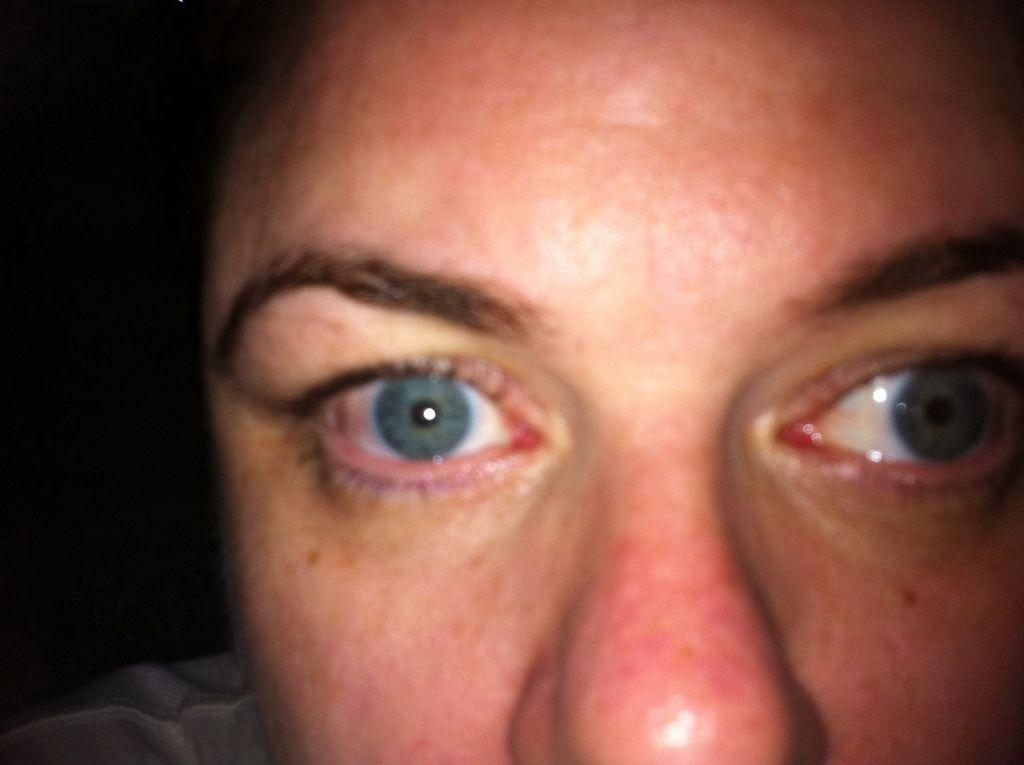What is the main subject of the image? There is a person's face in the image. Can you describe the background of the image? The background of the image is dark. Where is the cork placed during the feast in the image? There is no cork or feast present in the image; it only features a person's face with a dark background. 